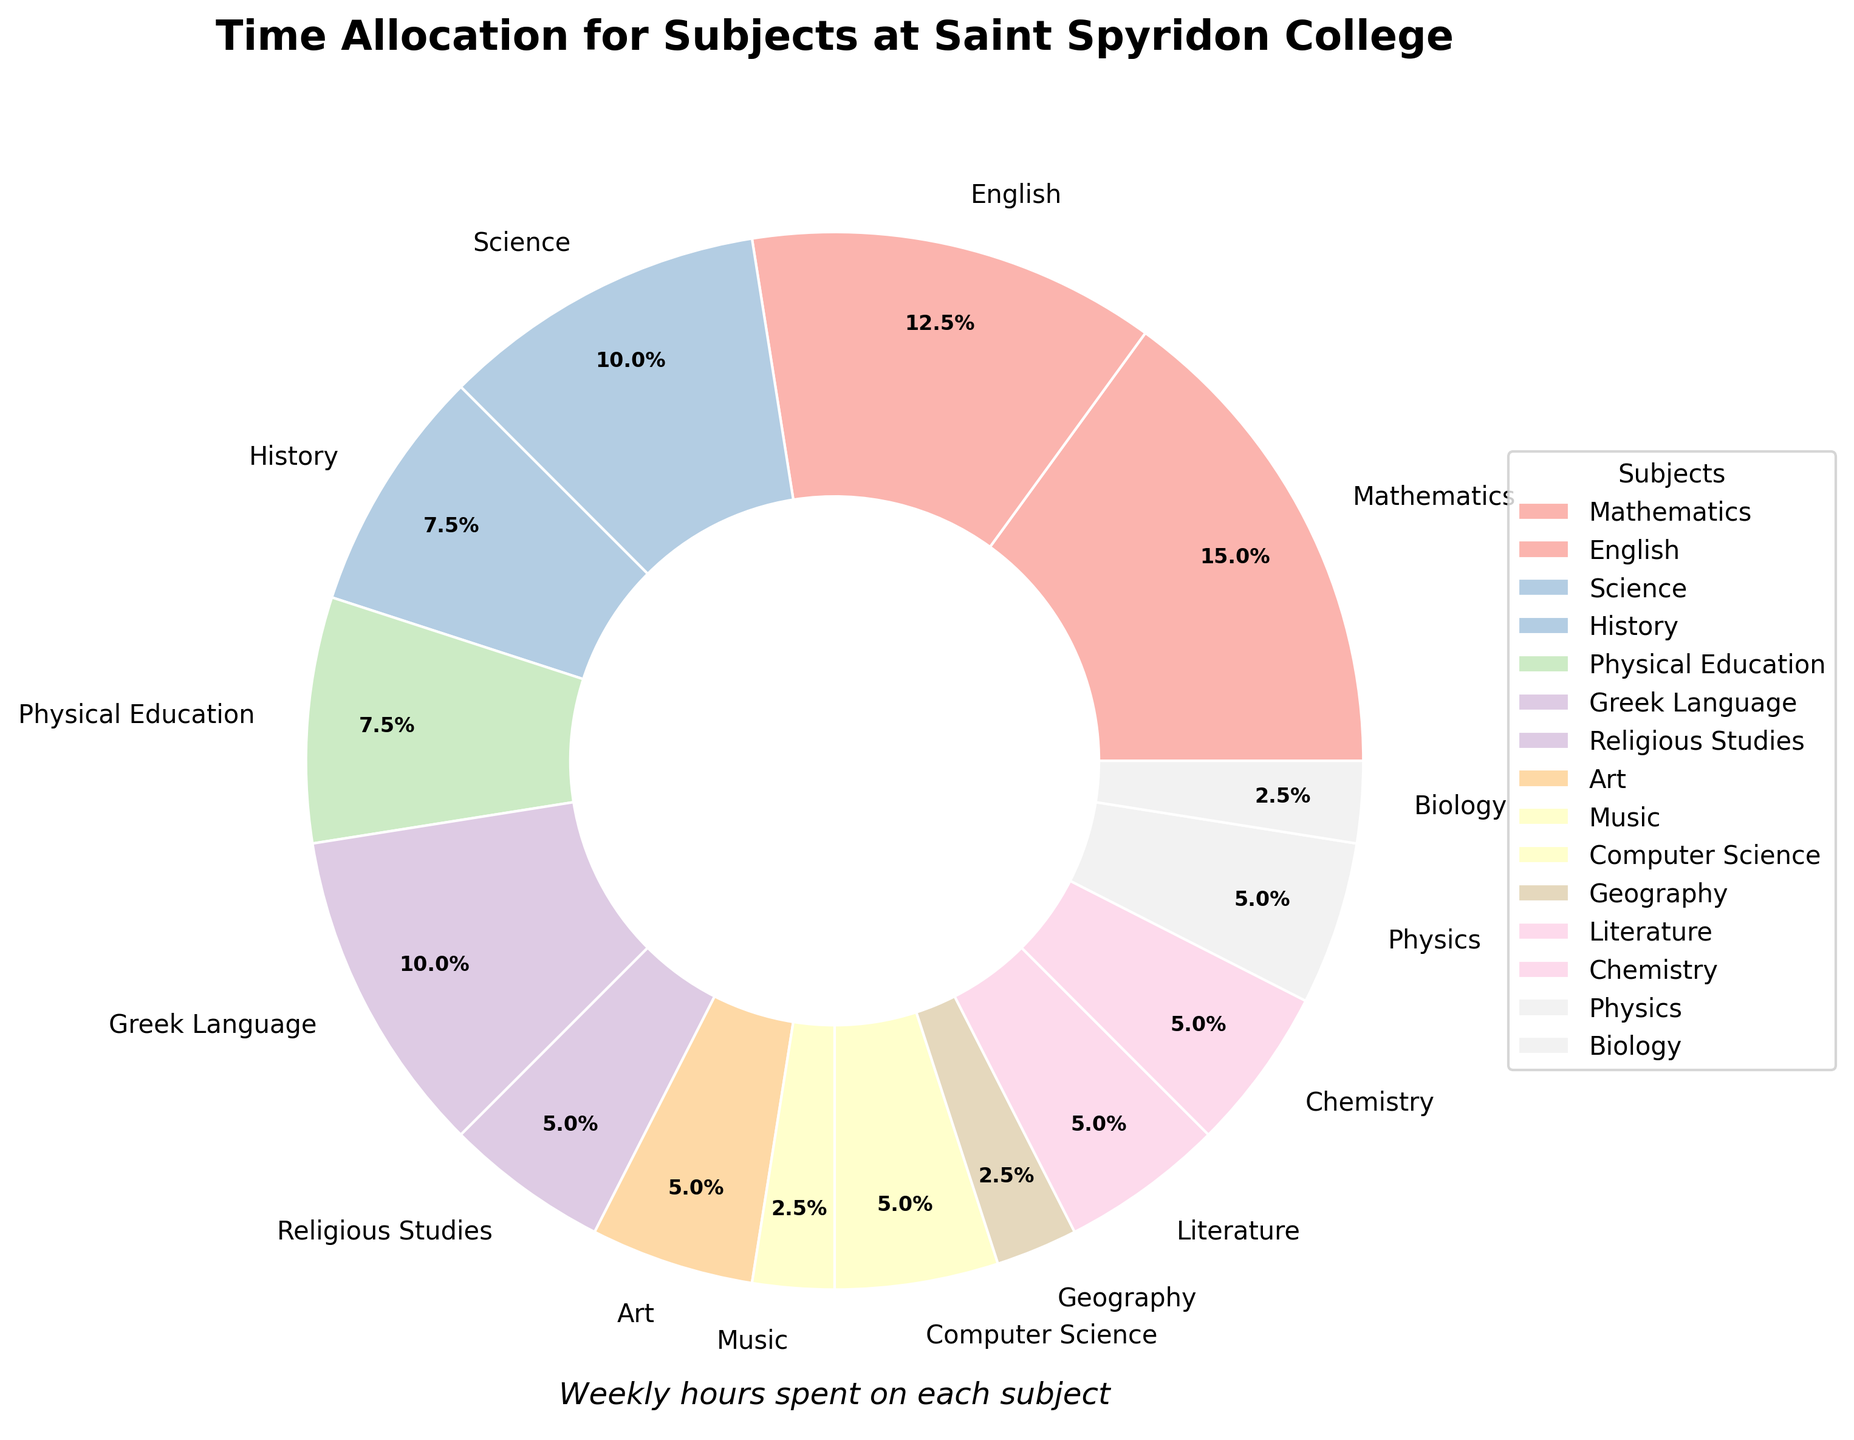What percentage of time do students spend on Mathematics compared to English? In the pie chart, the percentage for Mathematics is 22.6%, and for English, it is 18.9%. The comparison can be made directly with these values.
Answer: 22.6% vs. 18.9% Which subject has the least amount of time allocated to it? By looking at the pie chart, Music and Geography each occupy the smallest wedges. They both have 1 hour allocated.
Answer: Music and Geography How much total time is spent on subjects other than Mathematics and English? Add the weekly hours of all subjects excluding Mathematics (6 hours) and English (5 hours). Total = 4+3+3+4+2+2+1+2+1+2+2+2+1 = 29 hours.
Answer: 29 hours What are the common attributes of the segments for Art and Religious Studies? Art and Religious Studies share the same segment width in the pie chart, likely indicating the same number of hours (2 hours each), and both wedges are in pastel colors.
Answer: Equal width, pastel colors What subject takes up a visually larger proportion than Physical Education but less than Mathematics? In the pie chart, Greek Language (4 hours) fits this description as it is larger than Physical Education (3 hours) but smaller than Mathematics (6 hours).
Answer: Greek Language Which two subjects together account for the same number of hours as Science? Science has 4 hours. Both Biology (1 hour) and Chemistry (2 hours) combined with Geography (1 hour) will total to 4 hours.
Answer: Biology and Chemistry How much more time do students spend on Computer Science compared to Music? From the pie chart, Computer Science has 2 hours and Music has 1 hour. Time difference = 2 - 1 = 1 hour.
Answer: 1 hour Which subjects are allocated exactly 2 hours per week? The subjects with 2 hours are identified from the pie chart: Religious Studies, Chemistry, Physics, Literature, Art, and Computer Science.
Answer: Religious Studies, Chemistry, Physics, Literature, Art, Computer Science Is the time spent on History greater than or less than that on Greek Language? The pie chart shows History has 3 hours, whereas Greek Language has 4 hours. Therefore, History has less time allocated than Greek Language.
Answer: Less How do the combined hours of Physical Education, History, and Music compare to Mathematics? Combined hours for Physical Education, History, and Music: 3+3+1 = 7 hours. Mathematics has 6 hours. Therefore, the combined hours are greater.
Answer: Greater 